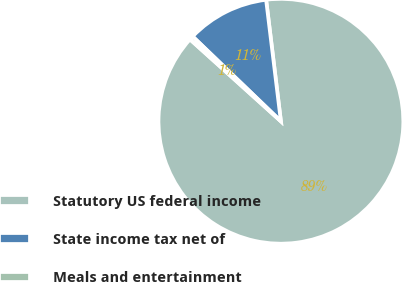Convert chart to OTSL. <chart><loc_0><loc_0><loc_500><loc_500><pie_chart><fcel>Statutory US federal income<fcel>State income tax net of<fcel>Meals and entertainment<nl><fcel>88.61%<fcel>10.89%<fcel>0.51%<nl></chart> 